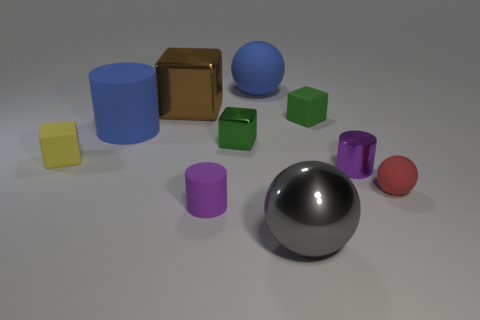What material is the cylinder that is the same color as the big rubber ball?
Keep it short and to the point. Rubber. Is there anything else that has the same shape as the tiny purple shiny object?
Provide a short and direct response. Yes. Are the gray object and the tiny red sphere made of the same material?
Keep it short and to the point. No. There is a rubber object that is right of the purple shiny object; is there a tiny yellow thing right of it?
Offer a very short reply. No. What number of purple cylinders are behind the red rubber object and on the left side of the big shiny ball?
Give a very brief answer. 0. What is the shape of the tiny shiny thing that is behind the small yellow rubber cube?
Offer a very short reply. Cube. How many other red objects are the same size as the red matte object?
Keep it short and to the point. 0. Does the tiny rubber block behind the yellow block have the same color as the big rubber cylinder?
Provide a short and direct response. No. There is a ball that is on the left side of the small shiny cylinder and behind the gray ball; what is its material?
Offer a terse response. Rubber. Is the number of big cyan things greater than the number of small purple cylinders?
Your answer should be very brief. No. 